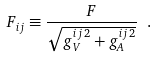Convert formula to latex. <formula><loc_0><loc_0><loc_500><loc_500>F _ { i j } \equiv \frac { F } { \sqrt { g ^ { i j \, 2 } _ { V } + g ^ { i j \, 2 } _ { A } } } \ .</formula> 